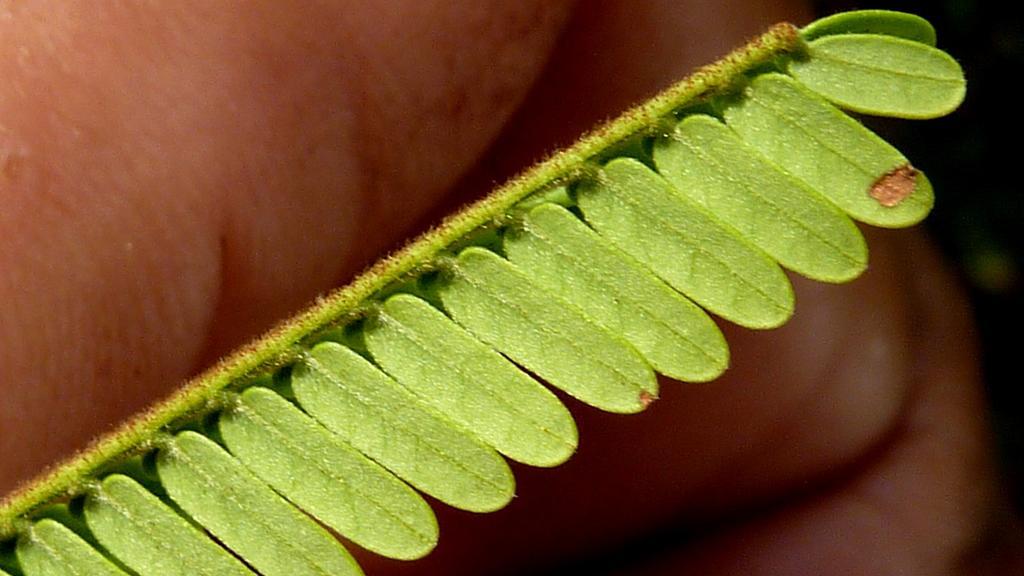In one or two sentences, can you explain what this image depicts? In this image we can see a stem with some leaves. 